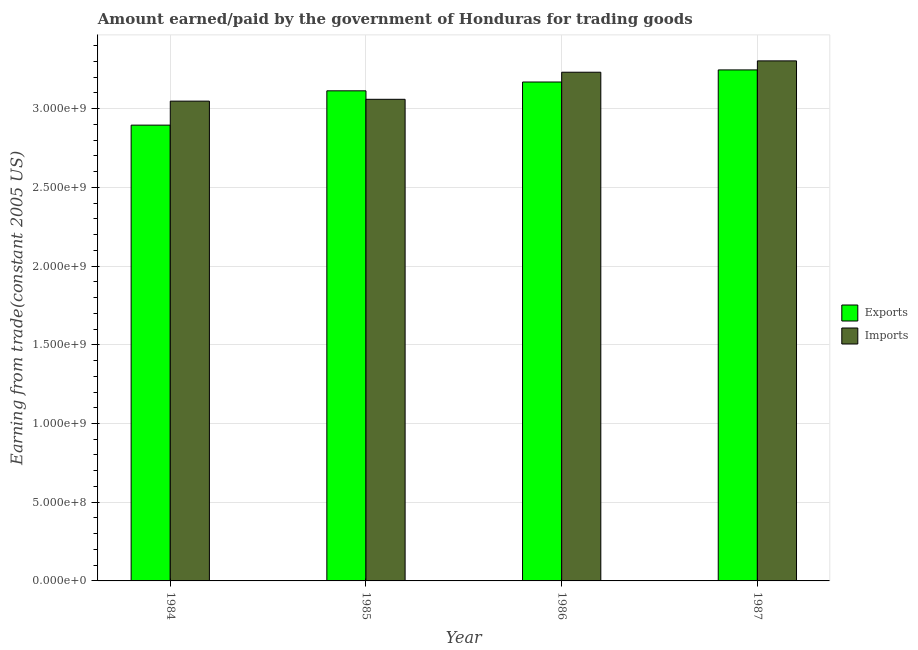Are the number of bars on each tick of the X-axis equal?
Make the answer very short. Yes. How many bars are there on the 4th tick from the left?
Keep it short and to the point. 2. What is the amount earned from exports in 1985?
Provide a short and direct response. 3.11e+09. Across all years, what is the maximum amount earned from exports?
Your response must be concise. 3.25e+09. Across all years, what is the minimum amount paid for imports?
Your answer should be very brief. 3.05e+09. What is the total amount paid for imports in the graph?
Your response must be concise. 1.26e+1. What is the difference between the amount paid for imports in 1986 and that in 1987?
Offer a terse response. -7.21e+07. What is the difference between the amount earned from exports in 1986 and the amount paid for imports in 1984?
Offer a terse response. 2.74e+08. What is the average amount earned from exports per year?
Your answer should be very brief. 3.11e+09. In the year 1986, what is the difference between the amount paid for imports and amount earned from exports?
Offer a terse response. 0. In how many years, is the amount earned from exports greater than 1300000000 US$?
Provide a succinct answer. 4. What is the ratio of the amount paid for imports in 1985 to that in 1986?
Offer a very short reply. 0.95. What is the difference between the highest and the second highest amount paid for imports?
Provide a short and direct response. 7.21e+07. What is the difference between the highest and the lowest amount paid for imports?
Keep it short and to the point. 2.56e+08. What does the 1st bar from the left in 1986 represents?
Keep it short and to the point. Exports. What does the 2nd bar from the right in 1985 represents?
Offer a very short reply. Exports. How many years are there in the graph?
Give a very brief answer. 4. What is the difference between two consecutive major ticks on the Y-axis?
Make the answer very short. 5.00e+08. Are the values on the major ticks of Y-axis written in scientific E-notation?
Your answer should be very brief. Yes. Does the graph contain grids?
Offer a terse response. Yes. Where does the legend appear in the graph?
Make the answer very short. Center right. How many legend labels are there?
Offer a very short reply. 2. How are the legend labels stacked?
Keep it short and to the point. Vertical. What is the title of the graph?
Keep it short and to the point. Amount earned/paid by the government of Honduras for trading goods. What is the label or title of the X-axis?
Keep it short and to the point. Year. What is the label or title of the Y-axis?
Provide a short and direct response. Earning from trade(constant 2005 US). What is the Earning from trade(constant 2005 US) in Exports in 1984?
Make the answer very short. 2.90e+09. What is the Earning from trade(constant 2005 US) of Imports in 1984?
Your answer should be very brief. 3.05e+09. What is the Earning from trade(constant 2005 US) in Exports in 1985?
Offer a very short reply. 3.11e+09. What is the Earning from trade(constant 2005 US) in Imports in 1985?
Ensure brevity in your answer.  3.06e+09. What is the Earning from trade(constant 2005 US) in Exports in 1986?
Your answer should be compact. 3.17e+09. What is the Earning from trade(constant 2005 US) in Imports in 1986?
Offer a very short reply. 3.23e+09. What is the Earning from trade(constant 2005 US) of Exports in 1987?
Your answer should be compact. 3.25e+09. What is the Earning from trade(constant 2005 US) of Imports in 1987?
Offer a very short reply. 3.30e+09. Across all years, what is the maximum Earning from trade(constant 2005 US) in Exports?
Provide a succinct answer. 3.25e+09. Across all years, what is the maximum Earning from trade(constant 2005 US) of Imports?
Your response must be concise. 3.30e+09. Across all years, what is the minimum Earning from trade(constant 2005 US) in Exports?
Your answer should be compact. 2.90e+09. Across all years, what is the minimum Earning from trade(constant 2005 US) in Imports?
Offer a terse response. 3.05e+09. What is the total Earning from trade(constant 2005 US) of Exports in the graph?
Provide a succinct answer. 1.24e+1. What is the total Earning from trade(constant 2005 US) in Imports in the graph?
Make the answer very short. 1.26e+1. What is the difference between the Earning from trade(constant 2005 US) in Exports in 1984 and that in 1985?
Provide a short and direct response. -2.18e+08. What is the difference between the Earning from trade(constant 2005 US) in Imports in 1984 and that in 1985?
Provide a short and direct response. -1.16e+07. What is the difference between the Earning from trade(constant 2005 US) in Exports in 1984 and that in 1986?
Provide a succinct answer. -2.74e+08. What is the difference between the Earning from trade(constant 2005 US) in Imports in 1984 and that in 1986?
Ensure brevity in your answer.  -1.84e+08. What is the difference between the Earning from trade(constant 2005 US) of Exports in 1984 and that in 1987?
Offer a terse response. -3.51e+08. What is the difference between the Earning from trade(constant 2005 US) in Imports in 1984 and that in 1987?
Keep it short and to the point. -2.56e+08. What is the difference between the Earning from trade(constant 2005 US) in Exports in 1985 and that in 1986?
Your answer should be compact. -5.60e+07. What is the difference between the Earning from trade(constant 2005 US) in Imports in 1985 and that in 1986?
Ensure brevity in your answer.  -1.72e+08. What is the difference between the Earning from trade(constant 2005 US) in Exports in 1985 and that in 1987?
Provide a short and direct response. -1.33e+08. What is the difference between the Earning from trade(constant 2005 US) of Imports in 1985 and that in 1987?
Offer a very short reply. -2.44e+08. What is the difference between the Earning from trade(constant 2005 US) in Exports in 1986 and that in 1987?
Provide a short and direct response. -7.68e+07. What is the difference between the Earning from trade(constant 2005 US) of Imports in 1986 and that in 1987?
Give a very brief answer. -7.21e+07. What is the difference between the Earning from trade(constant 2005 US) in Exports in 1984 and the Earning from trade(constant 2005 US) in Imports in 1985?
Ensure brevity in your answer.  -1.64e+08. What is the difference between the Earning from trade(constant 2005 US) of Exports in 1984 and the Earning from trade(constant 2005 US) of Imports in 1986?
Keep it short and to the point. -3.36e+08. What is the difference between the Earning from trade(constant 2005 US) of Exports in 1984 and the Earning from trade(constant 2005 US) of Imports in 1987?
Ensure brevity in your answer.  -4.08e+08. What is the difference between the Earning from trade(constant 2005 US) of Exports in 1985 and the Earning from trade(constant 2005 US) of Imports in 1986?
Your response must be concise. -1.18e+08. What is the difference between the Earning from trade(constant 2005 US) in Exports in 1985 and the Earning from trade(constant 2005 US) in Imports in 1987?
Your response must be concise. -1.90e+08. What is the difference between the Earning from trade(constant 2005 US) of Exports in 1986 and the Earning from trade(constant 2005 US) of Imports in 1987?
Offer a terse response. -1.34e+08. What is the average Earning from trade(constant 2005 US) in Exports per year?
Offer a very short reply. 3.11e+09. What is the average Earning from trade(constant 2005 US) of Imports per year?
Ensure brevity in your answer.  3.16e+09. In the year 1984, what is the difference between the Earning from trade(constant 2005 US) of Exports and Earning from trade(constant 2005 US) of Imports?
Give a very brief answer. -1.52e+08. In the year 1985, what is the difference between the Earning from trade(constant 2005 US) of Exports and Earning from trade(constant 2005 US) of Imports?
Give a very brief answer. 5.38e+07. In the year 1986, what is the difference between the Earning from trade(constant 2005 US) in Exports and Earning from trade(constant 2005 US) in Imports?
Give a very brief answer. -6.21e+07. In the year 1987, what is the difference between the Earning from trade(constant 2005 US) in Exports and Earning from trade(constant 2005 US) in Imports?
Ensure brevity in your answer.  -5.74e+07. What is the ratio of the Earning from trade(constant 2005 US) in Exports in 1984 to that in 1985?
Provide a succinct answer. 0.93. What is the ratio of the Earning from trade(constant 2005 US) in Imports in 1984 to that in 1985?
Offer a very short reply. 1. What is the ratio of the Earning from trade(constant 2005 US) of Exports in 1984 to that in 1986?
Your answer should be compact. 0.91. What is the ratio of the Earning from trade(constant 2005 US) in Imports in 1984 to that in 1986?
Provide a succinct answer. 0.94. What is the ratio of the Earning from trade(constant 2005 US) of Exports in 1984 to that in 1987?
Give a very brief answer. 0.89. What is the ratio of the Earning from trade(constant 2005 US) in Imports in 1984 to that in 1987?
Provide a succinct answer. 0.92. What is the ratio of the Earning from trade(constant 2005 US) in Exports in 1985 to that in 1986?
Your answer should be very brief. 0.98. What is the ratio of the Earning from trade(constant 2005 US) in Imports in 1985 to that in 1986?
Your answer should be compact. 0.95. What is the ratio of the Earning from trade(constant 2005 US) of Exports in 1985 to that in 1987?
Give a very brief answer. 0.96. What is the ratio of the Earning from trade(constant 2005 US) in Imports in 1985 to that in 1987?
Give a very brief answer. 0.93. What is the ratio of the Earning from trade(constant 2005 US) of Exports in 1986 to that in 1987?
Make the answer very short. 0.98. What is the ratio of the Earning from trade(constant 2005 US) in Imports in 1986 to that in 1987?
Give a very brief answer. 0.98. What is the difference between the highest and the second highest Earning from trade(constant 2005 US) of Exports?
Offer a terse response. 7.68e+07. What is the difference between the highest and the second highest Earning from trade(constant 2005 US) of Imports?
Keep it short and to the point. 7.21e+07. What is the difference between the highest and the lowest Earning from trade(constant 2005 US) of Exports?
Your response must be concise. 3.51e+08. What is the difference between the highest and the lowest Earning from trade(constant 2005 US) in Imports?
Your answer should be very brief. 2.56e+08. 